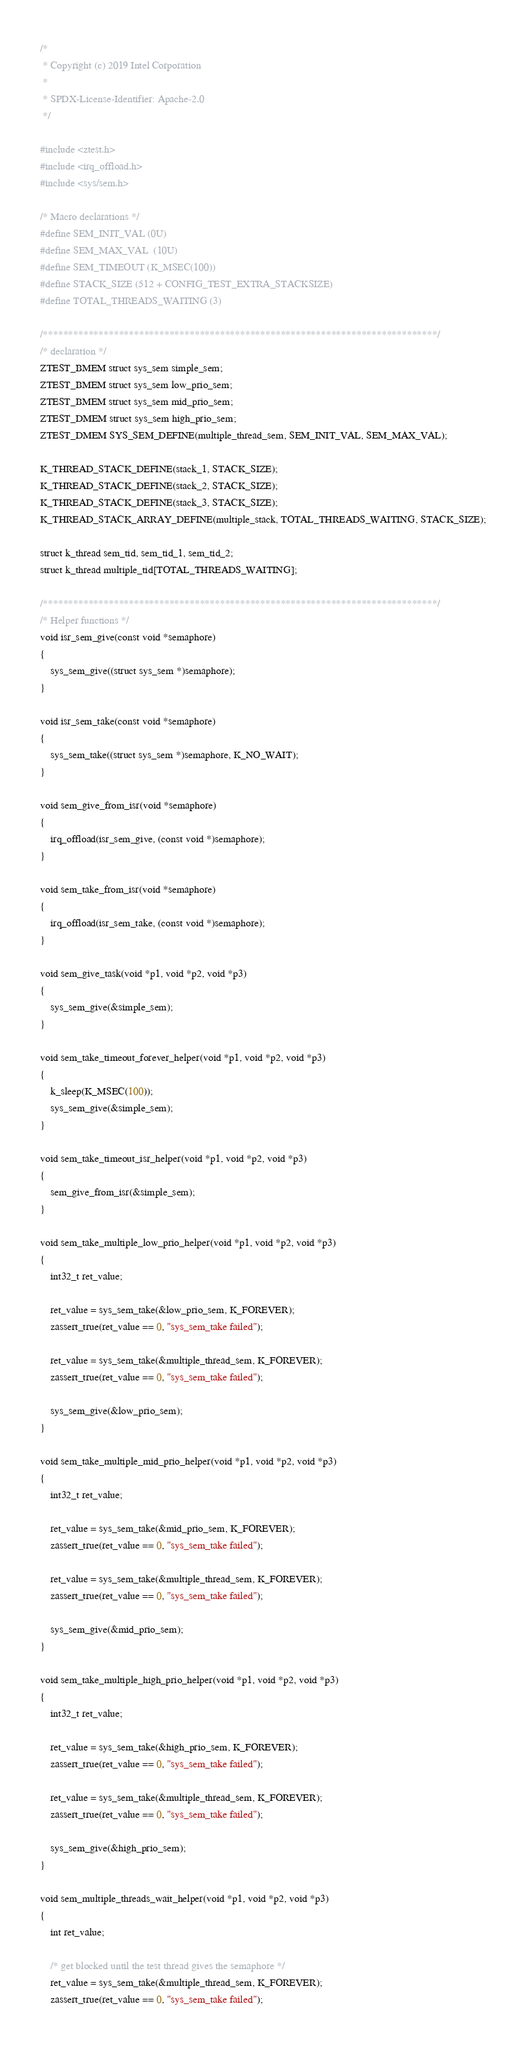Convert code to text. <code><loc_0><loc_0><loc_500><loc_500><_C_>/*
 * Copyright (c) 2019 Intel Corporation
 *
 * SPDX-License-Identifier: Apache-2.0
 */

#include <ztest.h>
#include <irq_offload.h>
#include <sys/sem.h>

/* Macro declarations */
#define SEM_INIT_VAL (0U)
#define SEM_MAX_VAL  (10U)
#define SEM_TIMEOUT (K_MSEC(100))
#define STACK_SIZE (512 + CONFIG_TEST_EXTRA_STACKSIZE)
#define TOTAL_THREADS_WAITING (3)

/******************************************************************************/
/* declaration */
ZTEST_BMEM struct sys_sem simple_sem;
ZTEST_BMEM struct sys_sem low_prio_sem;
ZTEST_BMEM struct sys_sem mid_prio_sem;
ZTEST_DMEM struct sys_sem high_prio_sem;
ZTEST_DMEM SYS_SEM_DEFINE(multiple_thread_sem, SEM_INIT_VAL, SEM_MAX_VAL);

K_THREAD_STACK_DEFINE(stack_1, STACK_SIZE);
K_THREAD_STACK_DEFINE(stack_2, STACK_SIZE);
K_THREAD_STACK_DEFINE(stack_3, STACK_SIZE);
K_THREAD_STACK_ARRAY_DEFINE(multiple_stack, TOTAL_THREADS_WAITING, STACK_SIZE);

struct k_thread sem_tid, sem_tid_1, sem_tid_2;
struct k_thread multiple_tid[TOTAL_THREADS_WAITING];

/******************************************************************************/
/* Helper functions */
void isr_sem_give(const void *semaphore)
{
	sys_sem_give((struct sys_sem *)semaphore);
}

void isr_sem_take(const void *semaphore)
{
	sys_sem_take((struct sys_sem *)semaphore, K_NO_WAIT);
}

void sem_give_from_isr(void *semaphore)
{
	irq_offload(isr_sem_give, (const void *)semaphore);
}

void sem_take_from_isr(void *semaphore)
{
	irq_offload(isr_sem_take, (const void *)semaphore);
}

void sem_give_task(void *p1, void *p2, void *p3)
{
	sys_sem_give(&simple_sem);
}

void sem_take_timeout_forever_helper(void *p1, void *p2, void *p3)
{
	k_sleep(K_MSEC(100));
	sys_sem_give(&simple_sem);
}

void sem_take_timeout_isr_helper(void *p1, void *p2, void *p3)
{
	sem_give_from_isr(&simple_sem);
}

void sem_take_multiple_low_prio_helper(void *p1, void *p2, void *p3)
{
	int32_t ret_value;

	ret_value = sys_sem_take(&low_prio_sem, K_FOREVER);
	zassert_true(ret_value == 0, "sys_sem_take failed");

	ret_value = sys_sem_take(&multiple_thread_sem, K_FOREVER);
	zassert_true(ret_value == 0, "sys_sem_take failed");

	sys_sem_give(&low_prio_sem);
}

void sem_take_multiple_mid_prio_helper(void *p1, void *p2, void *p3)
{
	int32_t ret_value;

	ret_value = sys_sem_take(&mid_prio_sem, K_FOREVER);
	zassert_true(ret_value == 0, "sys_sem_take failed");

	ret_value = sys_sem_take(&multiple_thread_sem, K_FOREVER);
	zassert_true(ret_value == 0, "sys_sem_take failed");

	sys_sem_give(&mid_prio_sem);
}

void sem_take_multiple_high_prio_helper(void *p1, void *p2, void *p3)
{
	int32_t ret_value;

	ret_value = sys_sem_take(&high_prio_sem, K_FOREVER);
	zassert_true(ret_value == 0, "sys_sem_take failed");

	ret_value = sys_sem_take(&multiple_thread_sem, K_FOREVER);
	zassert_true(ret_value == 0, "sys_sem_take failed");

	sys_sem_give(&high_prio_sem);
}

void sem_multiple_threads_wait_helper(void *p1, void *p2, void *p3)
{
	int ret_value;

	/* get blocked until the test thread gives the semaphore */
	ret_value = sys_sem_take(&multiple_thread_sem, K_FOREVER);
	zassert_true(ret_value == 0, "sys_sem_take failed");
</code> 